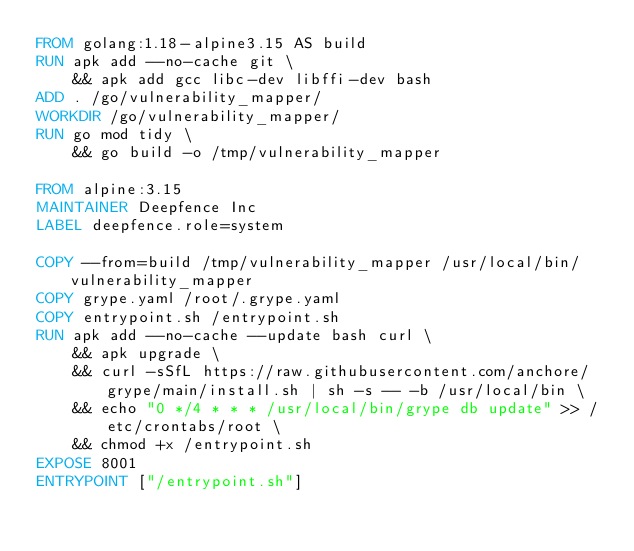Convert code to text. <code><loc_0><loc_0><loc_500><loc_500><_Dockerfile_>FROM golang:1.18-alpine3.15 AS build
RUN apk add --no-cache git \
    && apk add gcc libc-dev libffi-dev bash
ADD . /go/vulnerability_mapper/
WORKDIR /go/vulnerability_mapper/
RUN go mod tidy \
    && go build -o /tmp/vulnerability_mapper

FROM alpine:3.15
MAINTAINER Deepfence Inc
LABEL deepfence.role=system

COPY --from=build /tmp/vulnerability_mapper /usr/local/bin/vulnerability_mapper
COPY grype.yaml /root/.grype.yaml
COPY entrypoint.sh /entrypoint.sh
RUN apk add --no-cache --update bash curl \
    && apk upgrade \
    && curl -sSfL https://raw.githubusercontent.com/anchore/grype/main/install.sh | sh -s -- -b /usr/local/bin \
    && echo "0 */4 * * * /usr/local/bin/grype db update" >> /etc/crontabs/root \
    && chmod +x /entrypoint.sh
EXPOSE 8001
ENTRYPOINT ["/entrypoint.sh"]</code> 